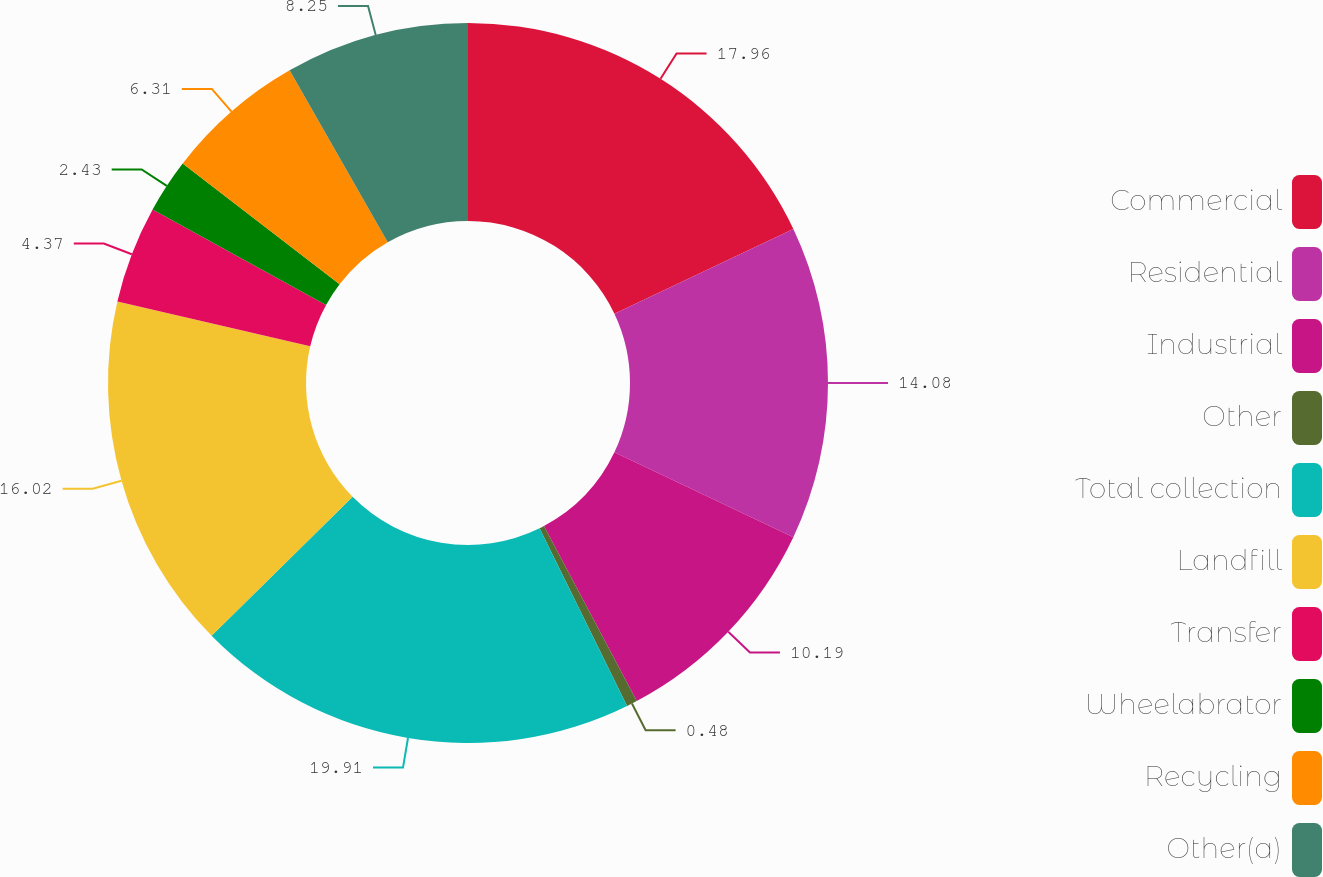<chart> <loc_0><loc_0><loc_500><loc_500><pie_chart><fcel>Commercial<fcel>Residential<fcel>Industrial<fcel>Other<fcel>Total collection<fcel>Landfill<fcel>Transfer<fcel>Wheelabrator<fcel>Recycling<fcel>Other(a)<nl><fcel>17.96%<fcel>14.08%<fcel>10.19%<fcel>0.48%<fcel>19.9%<fcel>16.02%<fcel>4.37%<fcel>2.43%<fcel>6.31%<fcel>8.25%<nl></chart> 